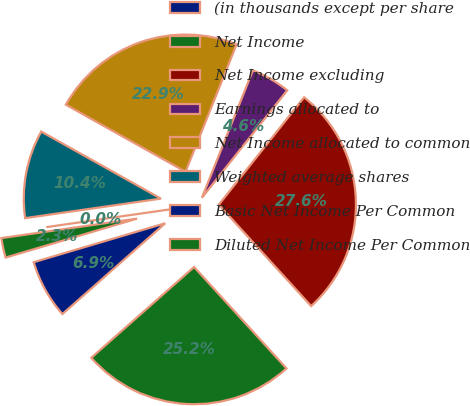<chart> <loc_0><loc_0><loc_500><loc_500><pie_chart><fcel>(in thousands except per share<fcel>Net Income<fcel>Net Income excluding<fcel>Earnings allocated to<fcel>Net Income allocated to common<fcel>Weighted average shares<fcel>Basic Net Income Per Common<fcel>Diluted Net Income Per Common<nl><fcel>6.93%<fcel>25.25%<fcel>27.56%<fcel>4.62%<fcel>22.94%<fcel>10.4%<fcel>0.0%<fcel>2.31%<nl></chart> 